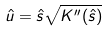<formula> <loc_0><loc_0><loc_500><loc_500>\hat { u } = \hat { s } \sqrt { K ^ { \prime \prime } ( \hat { s } ) }</formula> 